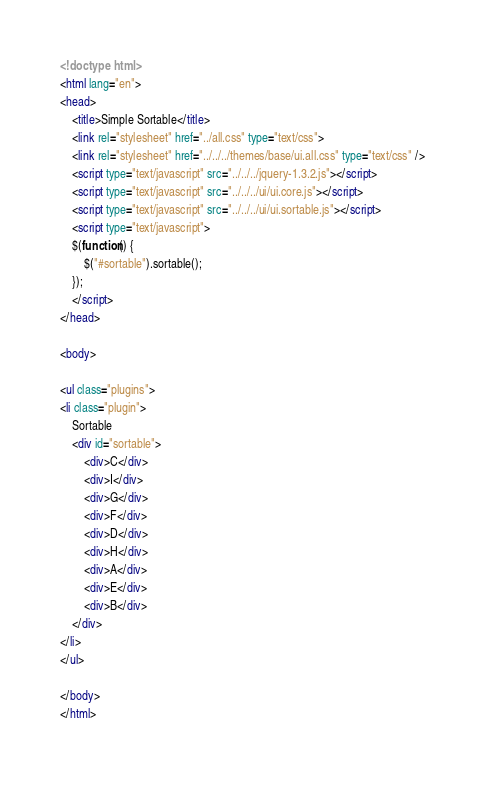Convert code to text. <code><loc_0><loc_0><loc_500><loc_500><_HTML_><!doctype html>
<html lang="en">
<head>
	<title>Simple Sortable</title>
	<link rel="stylesheet" href="../all.css" type="text/css">
	<link rel="stylesheet" href="../../../themes/base/ui.all.css" type="text/css" />
	<script type="text/javascript" src="../../../jquery-1.3.2.js"></script>
	<script type="text/javascript" src="../../../ui/ui.core.js"></script>
	<script type="text/javascript" src="../../../ui/ui.sortable.js"></script>
	<script type="text/javascript">
	$(function() {
		$("#sortable").sortable();
	});
	</script>
</head>

<body>

<ul class="plugins">
<li class="plugin">
	Sortable
	<div id="sortable">
		<div>C</div>
		<div>I</div>
		<div>G</div>
		<div>F</div>
		<div>D</div>
		<div>H</div>
		<div>A</div>
		<div>E</div>
		<div>B</div>
	</div>
</li>
</ul>

</body>
</html>
</code> 